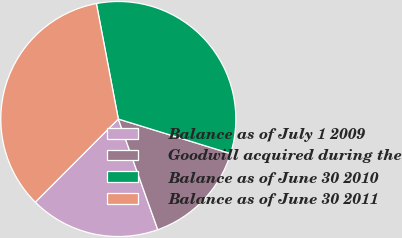Convert chart to OTSL. <chart><loc_0><loc_0><loc_500><loc_500><pie_chart><fcel>Balance as of July 1 2009<fcel>Goodwill acquired during the<fcel>Balance as of June 30 2010<fcel>Balance as of June 30 2011<nl><fcel>17.94%<fcel>14.79%<fcel>32.74%<fcel>34.53%<nl></chart> 